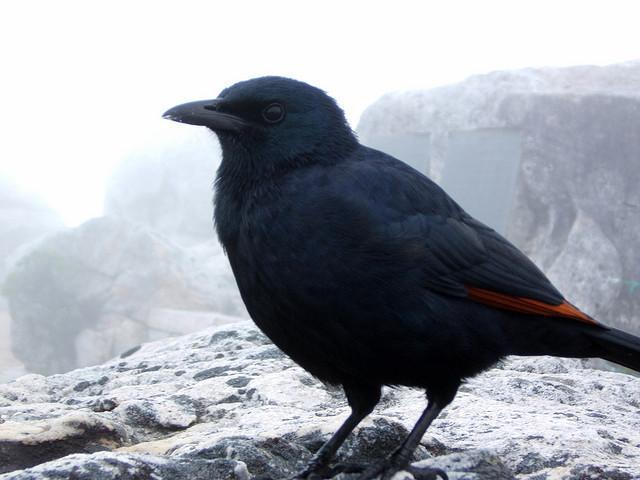How many birds can be seen?
Give a very brief answer. 1. 